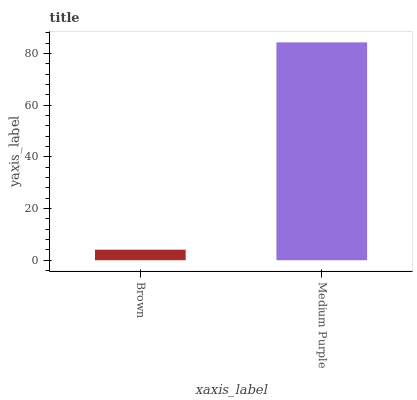Is Brown the minimum?
Answer yes or no. Yes. Is Medium Purple the maximum?
Answer yes or no. Yes. Is Medium Purple the minimum?
Answer yes or no. No. Is Medium Purple greater than Brown?
Answer yes or no. Yes. Is Brown less than Medium Purple?
Answer yes or no. Yes. Is Brown greater than Medium Purple?
Answer yes or no. No. Is Medium Purple less than Brown?
Answer yes or no. No. Is Medium Purple the high median?
Answer yes or no. Yes. Is Brown the low median?
Answer yes or no. Yes. Is Brown the high median?
Answer yes or no. No. Is Medium Purple the low median?
Answer yes or no. No. 